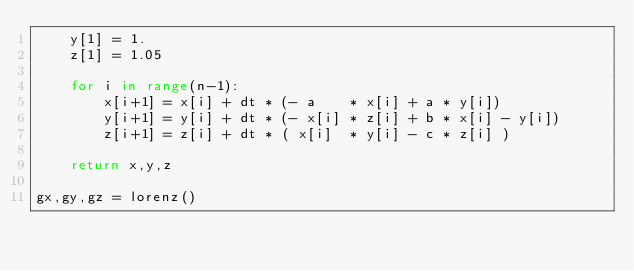<code> <loc_0><loc_0><loc_500><loc_500><_Python_>    y[1] = 1.
    z[1] = 1.05

    for i in range(n-1):
        x[i+1] = x[i] + dt * (- a    * x[i] + a * y[i])
        y[i+1] = y[i] + dt * (- x[i] * z[i] + b * x[i] - y[i])
        z[i+1] = z[i] + dt * ( x[i]  * y[i] - c * z[i] )

    return x,y,z

gx,gy,gz = lorenz()
</code> 